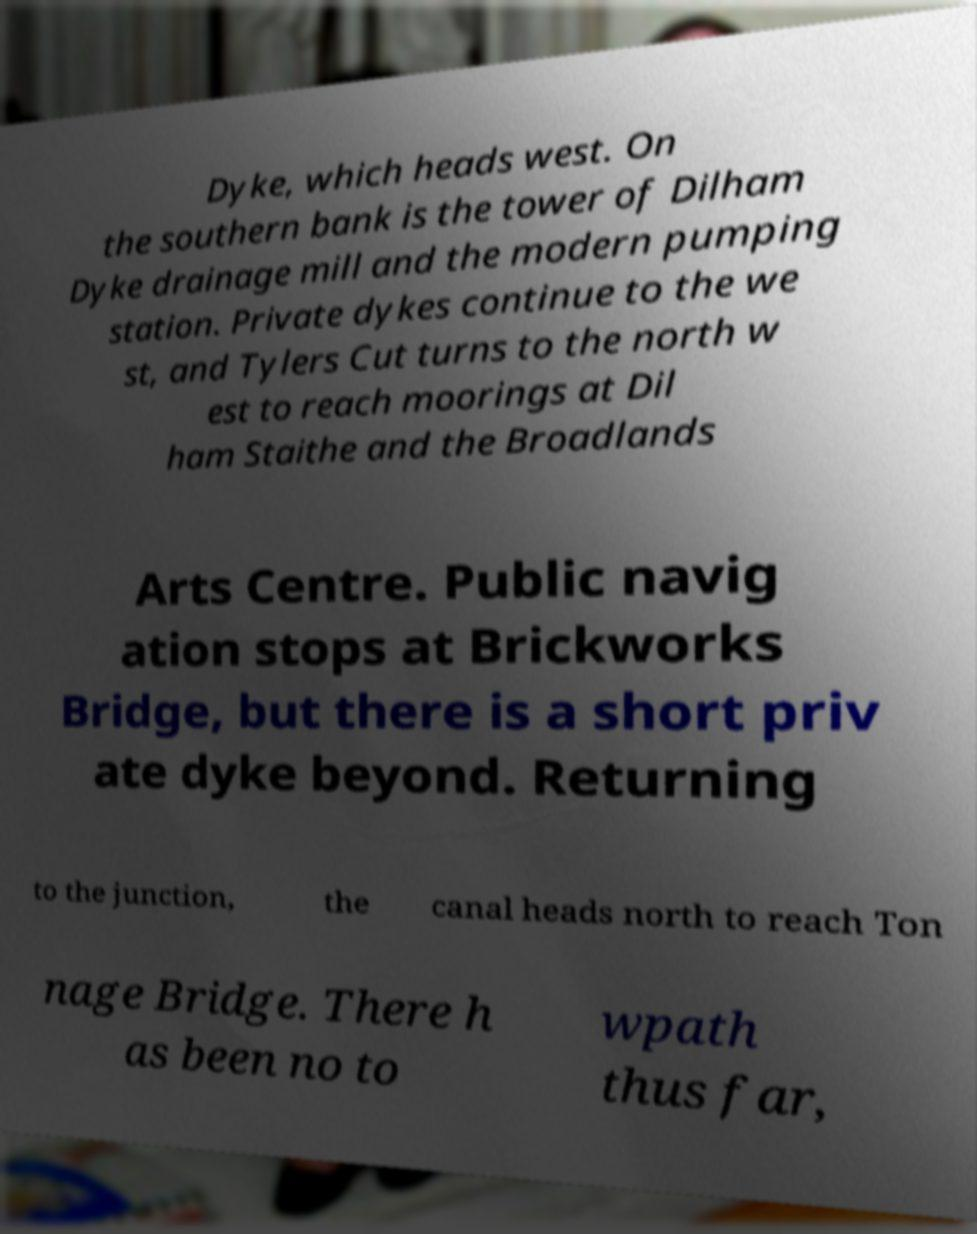Please identify and transcribe the text found in this image. Dyke, which heads west. On the southern bank is the tower of Dilham Dyke drainage mill and the modern pumping station. Private dykes continue to the we st, and Tylers Cut turns to the north w est to reach moorings at Dil ham Staithe and the Broadlands Arts Centre. Public navig ation stops at Brickworks Bridge, but there is a short priv ate dyke beyond. Returning to the junction, the canal heads north to reach Ton nage Bridge. There h as been no to wpath thus far, 